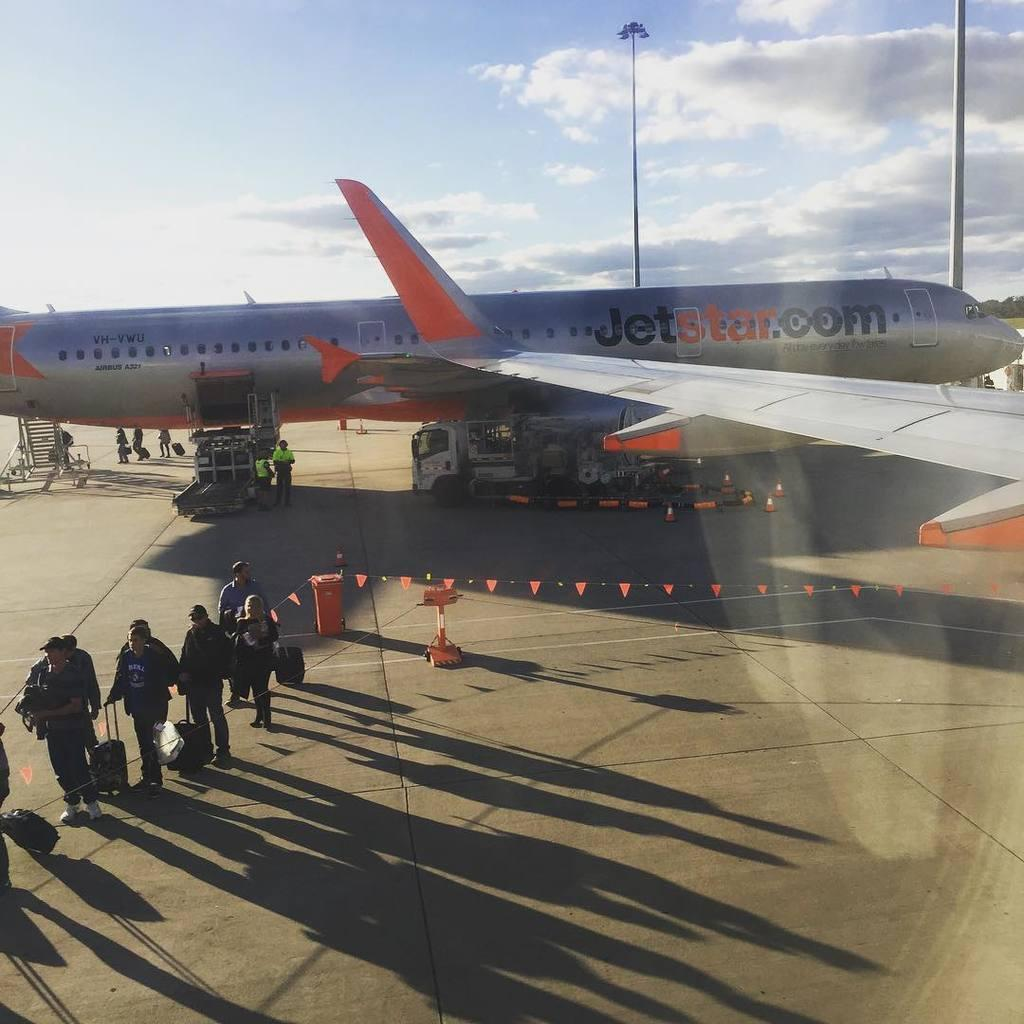Provide a one-sentence caption for the provided image. People walk away from a Jetstar plane at the airport. 